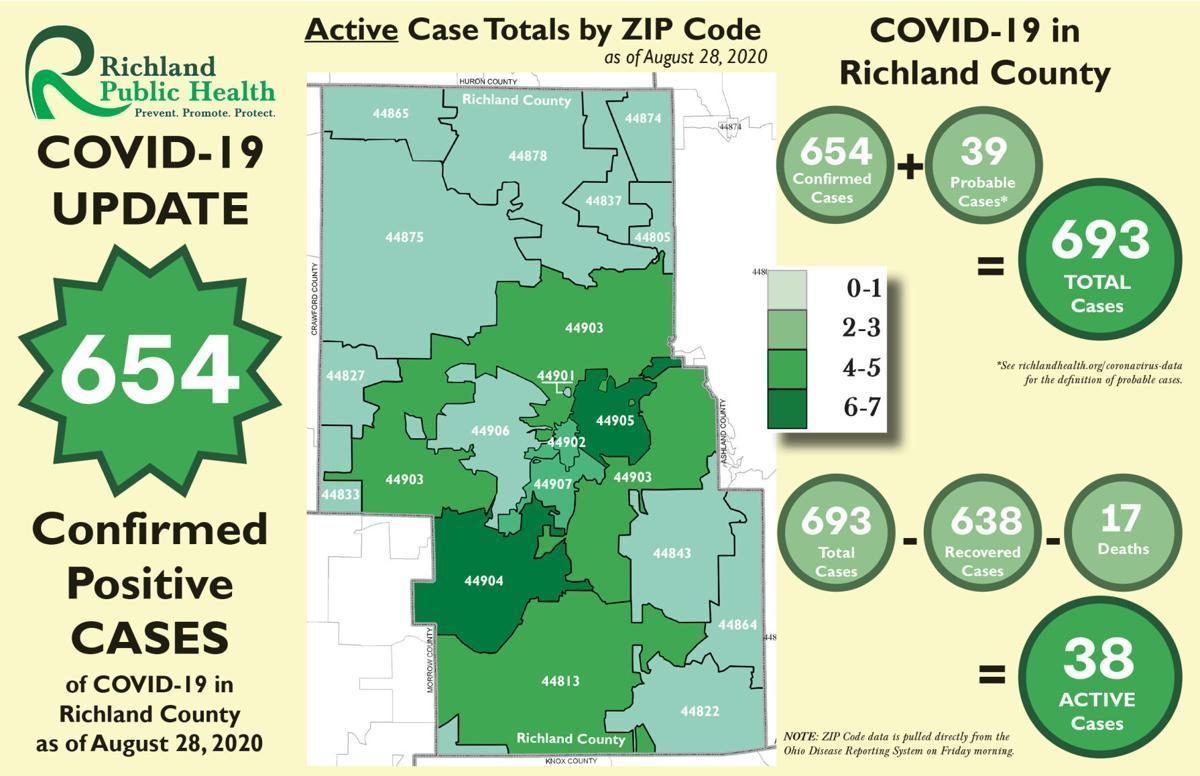How many recovered cases of COVID-19 were reported in Richland county as of August 28, 2020?
Answer the question with a short phrase. 638 How many active COVID-19 cases were reported in Richland county as of August 28, 2020? 38 What is the number of COVID-19 deaths reported in Richland county as of August 28, 2020? 17 How many confirmed positive cases of COVID-19 were reported in Richland county as of August 28, 2020? 654 What is the total number of COVID-19 cases reported in Richland county as of August 28, 2020? 693 